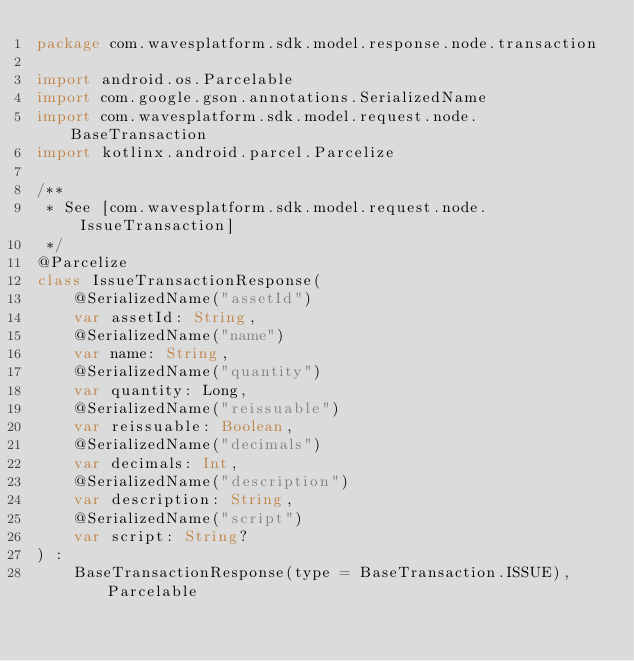<code> <loc_0><loc_0><loc_500><loc_500><_Kotlin_>package com.wavesplatform.sdk.model.response.node.transaction

import android.os.Parcelable
import com.google.gson.annotations.SerializedName
import com.wavesplatform.sdk.model.request.node.BaseTransaction
import kotlinx.android.parcel.Parcelize

/**
 * See [com.wavesplatform.sdk.model.request.node.IssueTransaction]
 */
@Parcelize
class IssueTransactionResponse(
    @SerializedName("assetId")
    var assetId: String,
    @SerializedName("name")
    var name: String,
    @SerializedName("quantity")
    var quantity: Long,
    @SerializedName("reissuable")
    var reissuable: Boolean,
    @SerializedName("decimals")
    var decimals: Int,
    @SerializedName("description")
    var description: String,
    @SerializedName("script")
    var script: String?
) :
    BaseTransactionResponse(type = BaseTransaction.ISSUE), Parcelable
</code> 